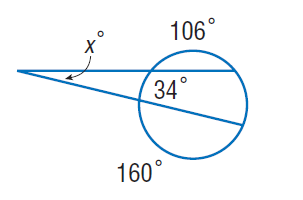Question: Find x. Assume that any segment that appears to be tangent is tangent.
Choices:
A. 13
B. 34
C. 106
D. 160
Answer with the letter. Answer: A 